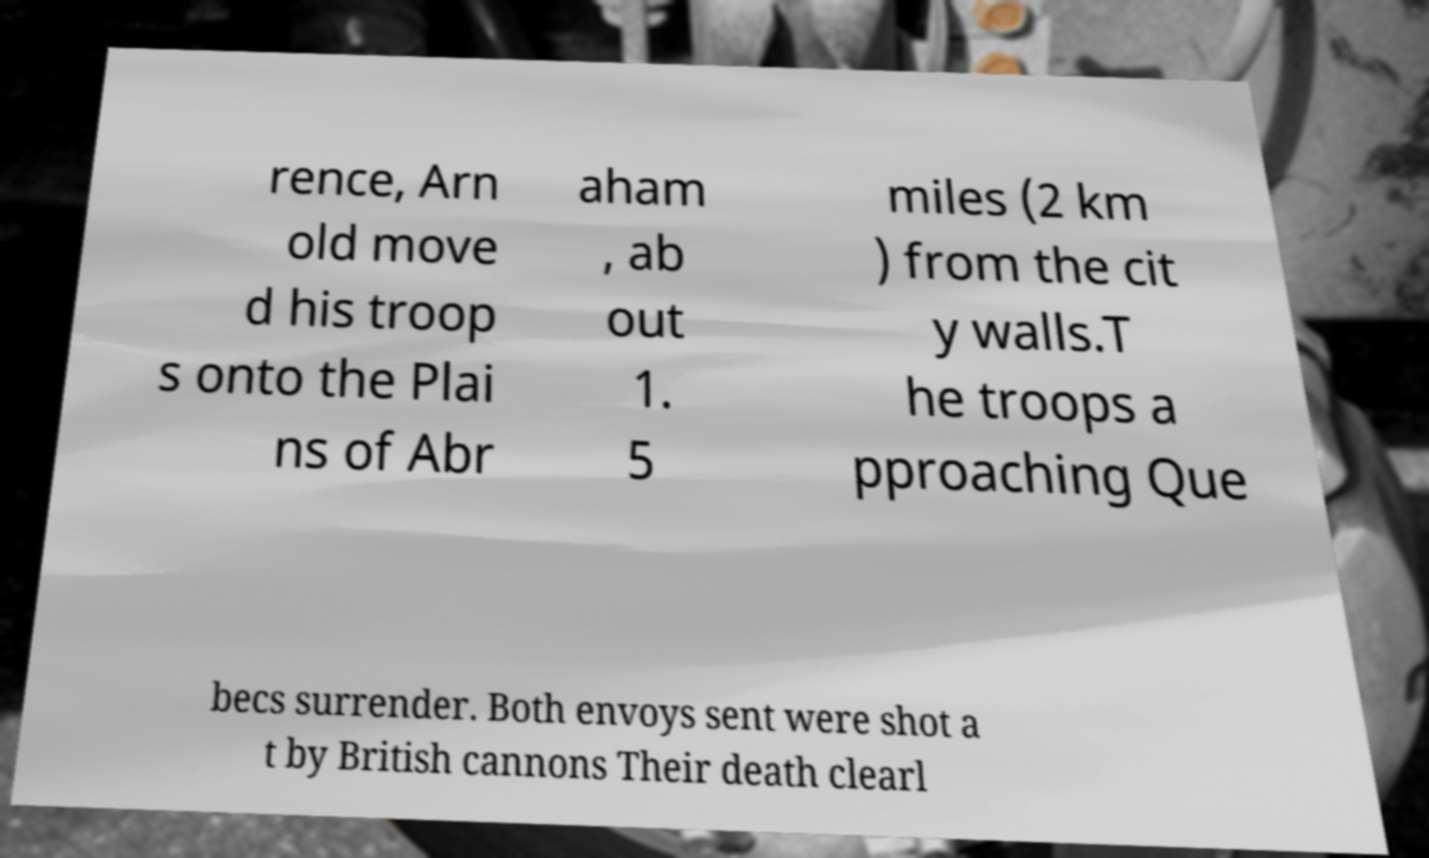For documentation purposes, I need the text within this image transcribed. Could you provide that? rence, Arn old move d his troop s onto the Plai ns of Abr aham , ab out 1. 5 miles (2 km ) from the cit y walls.T he troops a pproaching Que becs surrender. Both envoys sent were shot a t by British cannons Their death clearl 